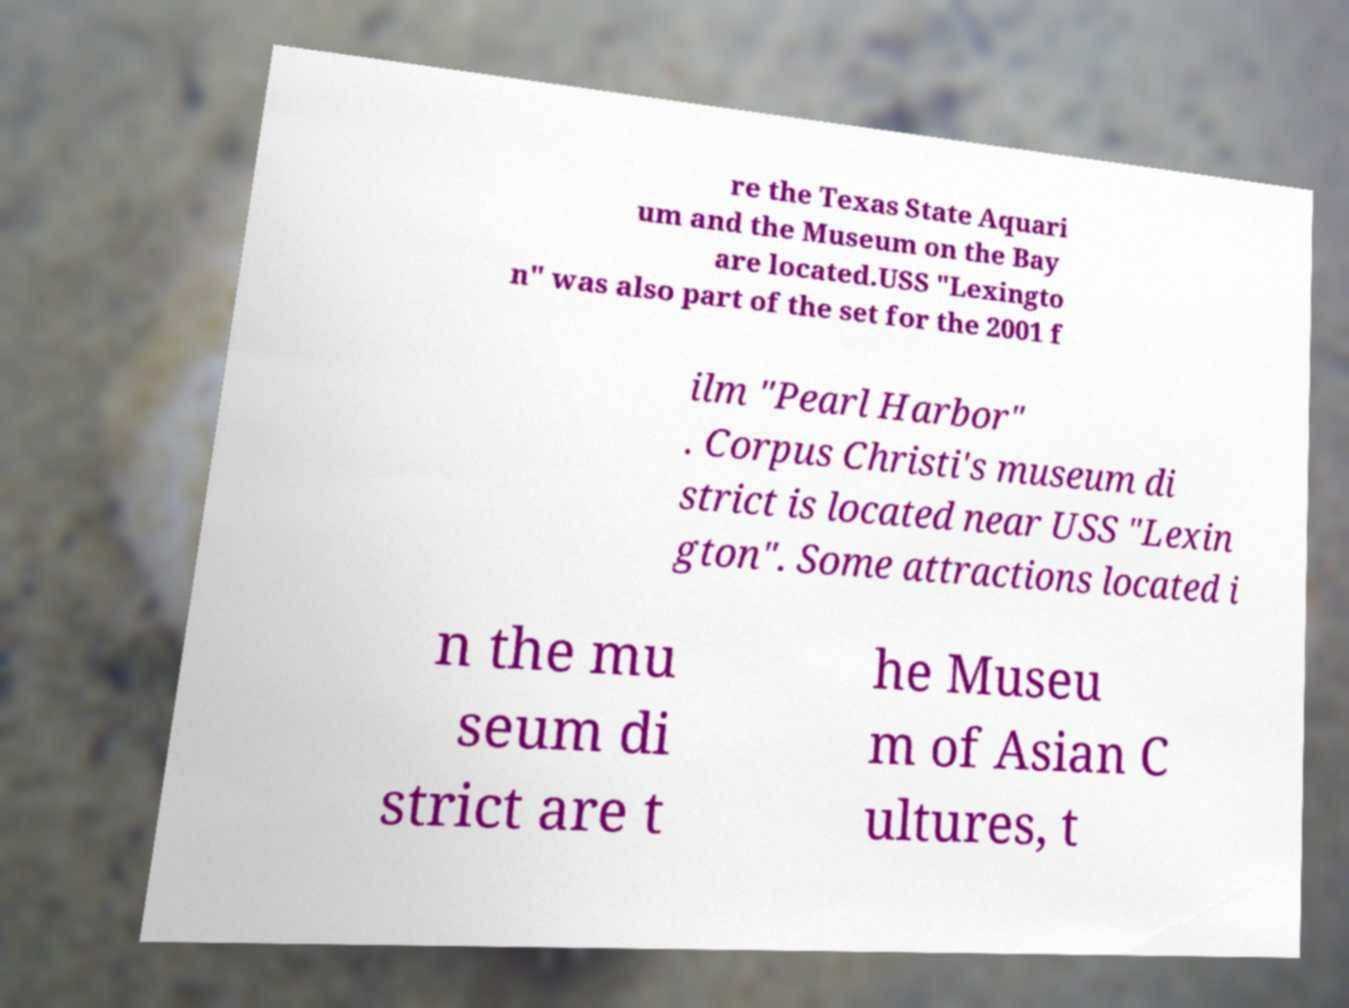Please read and relay the text visible in this image. What does it say? re the Texas State Aquari um and the Museum on the Bay are located.USS "Lexingto n" was also part of the set for the 2001 f ilm "Pearl Harbor" . Corpus Christi's museum di strict is located near USS "Lexin gton". Some attractions located i n the mu seum di strict are t he Museu m of Asian C ultures, t 